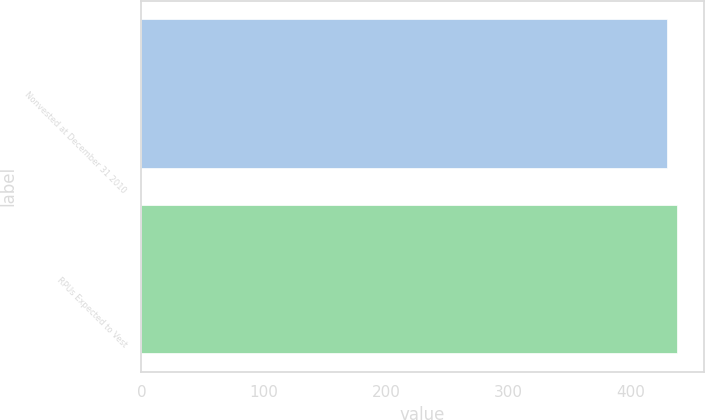Convert chart to OTSL. <chart><loc_0><loc_0><loc_500><loc_500><bar_chart><fcel>Nonvested at December 31 2010<fcel>RPUs Expected to Vest<nl><fcel>430<fcel>438<nl></chart> 